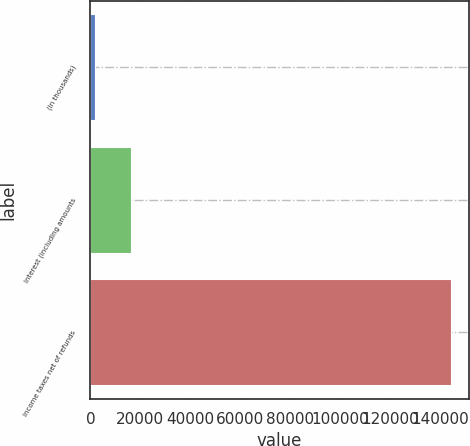Convert chart. <chart><loc_0><loc_0><loc_500><loc_500><bar_chart><fcel>(In thousands)<fcel>Interest (including amounts<fcel>Income taxes net of refunds<nl><fcel>2014<fcel>16244.9<fcel>144323<nl></chart> 